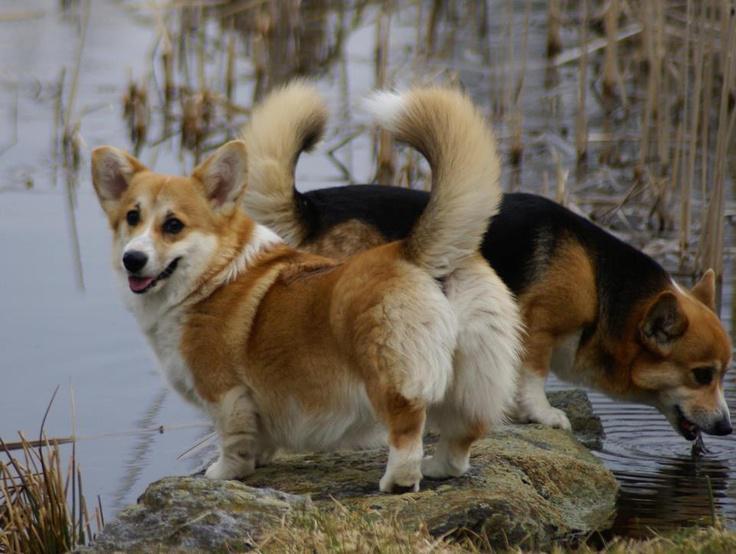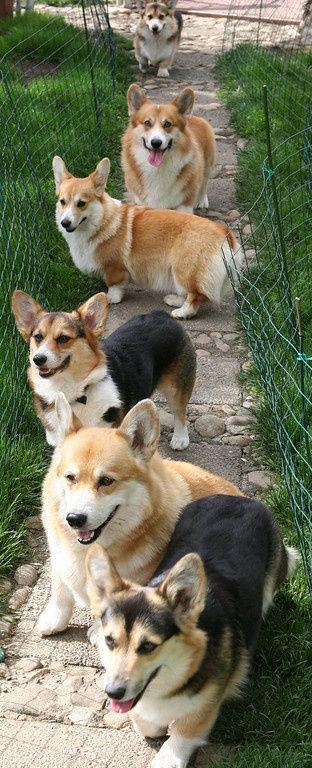The first image is the image on the left, the second image is the image on the right. Evaluate the accuracy of this statement regarding the images: "The left image contains no more than two corgi dogs.". Is it true? Answer yes or no. Yes. 